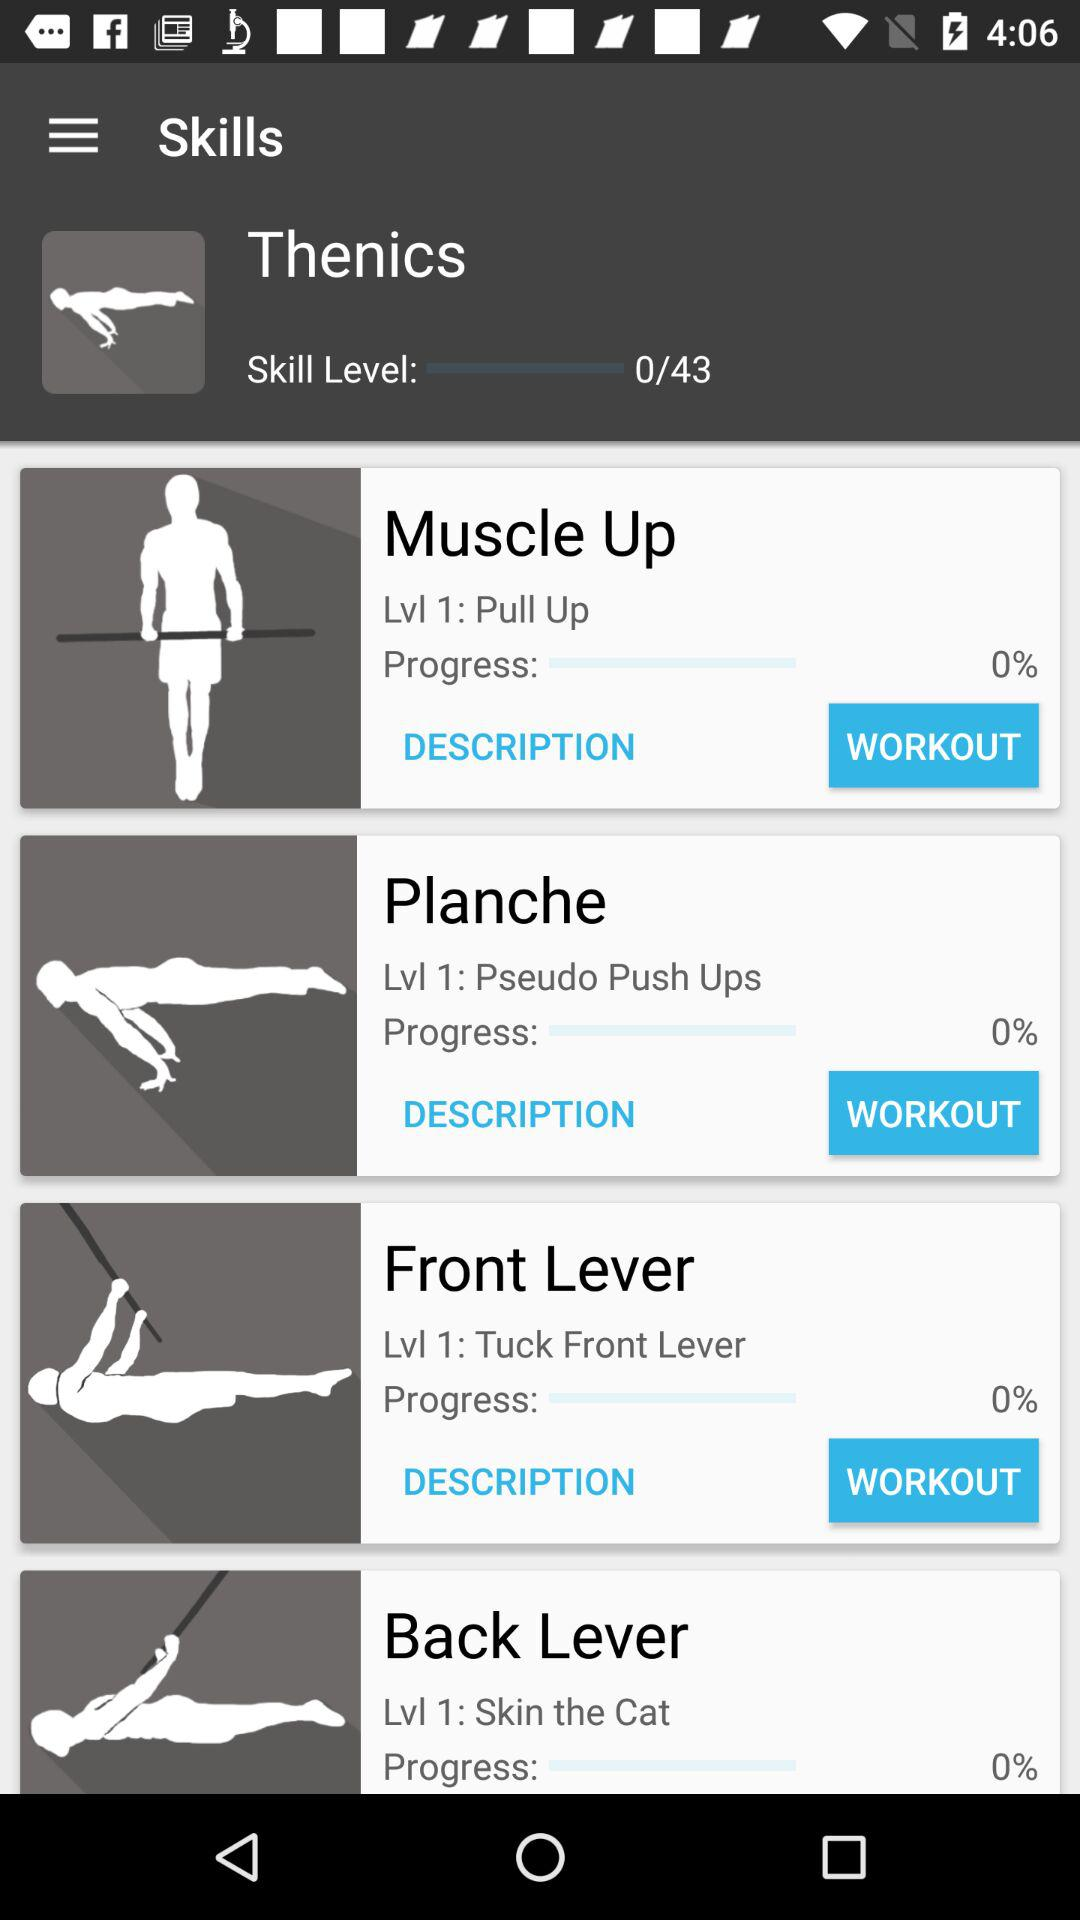How many skills are there in total?
Answer the question using a single word or phrase. 4 